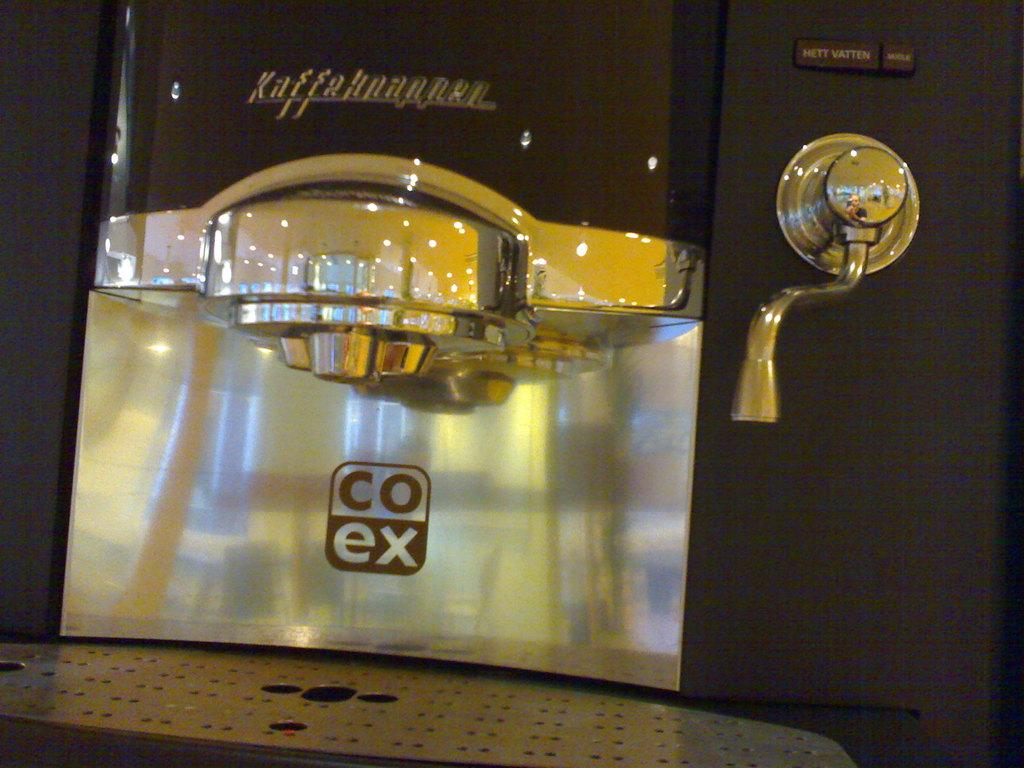Provide a one-sentence caption for the provided image. A clean and shiny coffee machine has co ex labeled on it. 